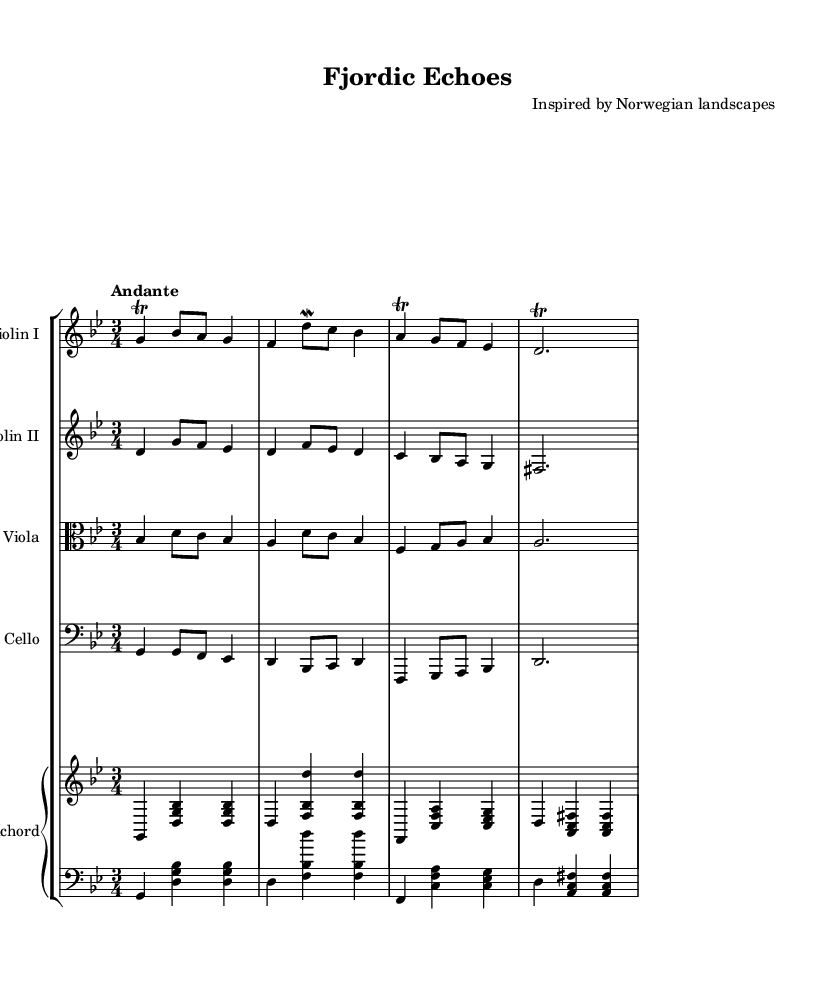What is the key signature of this music? The key signature is indicated at the beginning of the sheet music, showing a flat on the B line, which corresponds to B flat. This indicates that the piece is in G minor, as G minor has two flats (B flat and E flat).
Answer: G minor What is the time signature of this music? The time signature is at the beginning of the music, written as 3/4. This means there are three beats in each measure and the quarter note gets one beat.
Answer: 3/4 What is the tempo marking of this piece? The tempo is indicated above the staff, labeled "Andante." Andante typically means a moderate pace, which is a common tempo in Baroque music.
Answer: Andante How many instruments are featured in the score? By counting the unique instrument staffs in the score, we see that there are five staffs representing various instruments: two violins, a viola, a cello, and a harpsichord.
Answer: Five What are the dynamics indicated in the music? The dynamics refer to the loudness or softness indicated in the music. In the provided sections, there are no explicit dynamic markings shown. This suggests performers should interpret dynamics based on their understanding of the style, as is often the case in Baroque music.
Answer: None Which instruments play trills in this composition? Trills are a specific ornamentation shown in the notes, indicated by the symbol above the notes. In this piece, the trills appear on notes played by the first violin and the cello, showing these instruments are incorporating this ornamentation.
Answer: Violin I and cello What is the overall tonal center of this piece? The tonal center can often be inferred by the key signature and is confirmed by the starting note of the melody. Since this composition is in G minor, the tonal center is G.
Answer: G 